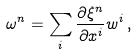<formula> <loc_0><loc_0><loc_500><loc_500>\omega ^ { n } = \sum _ { i } \frac { \partial \xi ^ { n } } { \partial x ^ { i } } w ^ { i } \, ,</formula> 